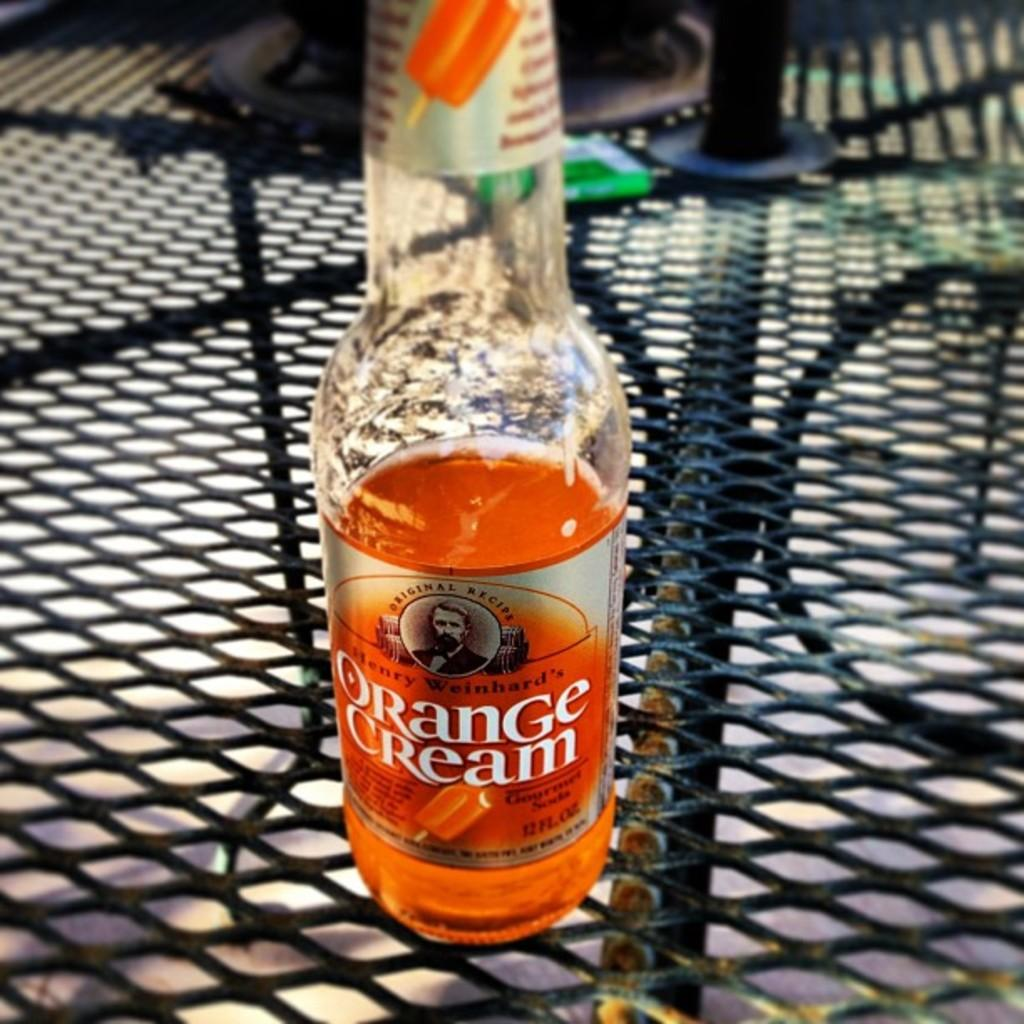<image>
Provide a brief description of the given image. A glass bottle half full of Orange Cream soda from Henry Weinhard. 